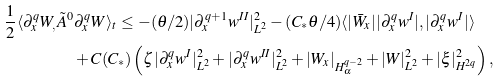<formula> <loc_0><loc_0><loc_500><loc_500>\frac { 1 } { 2 } \langle \partial _ { x } ^ { q } W _ { , } \tilde { A } ^ { 0 } & \partial _ { x } ^ { q } W \rangle _ { t } \leq - ( \theta / 2 ) | \partial _ { x } ^ { q + 1 } w ^ { I I } | _ { L ^ { 2 } } ^ { 2 } - ( C _ { * } \theta / 4 ) \langle | \bar { W } _ { x } | | \partial _ { x } ^ { q } w ^ { I } | , | \partial _ { x } ^ { q } w ^ { I } | \rangle \\ & + C ( C _ { * } ) \left ( \zeta | \partial _ { x } ^ { q } w ^ { I } | _ { L ^ { 2 } } ^ { 2 } + | \partial _ { x } ^ { q } w ^ { I I } | _ { L ^ { 2 } } ^ { 2 } + | W _ { x } | _ { H ^ { q - 2 } _ { \alpha } } + | W | _ { L ^ { 2 } } ^ { 2 } + | \xi | ^ { 2 } _ { H ^ { 2 q } } \right ) , \\</formula> 